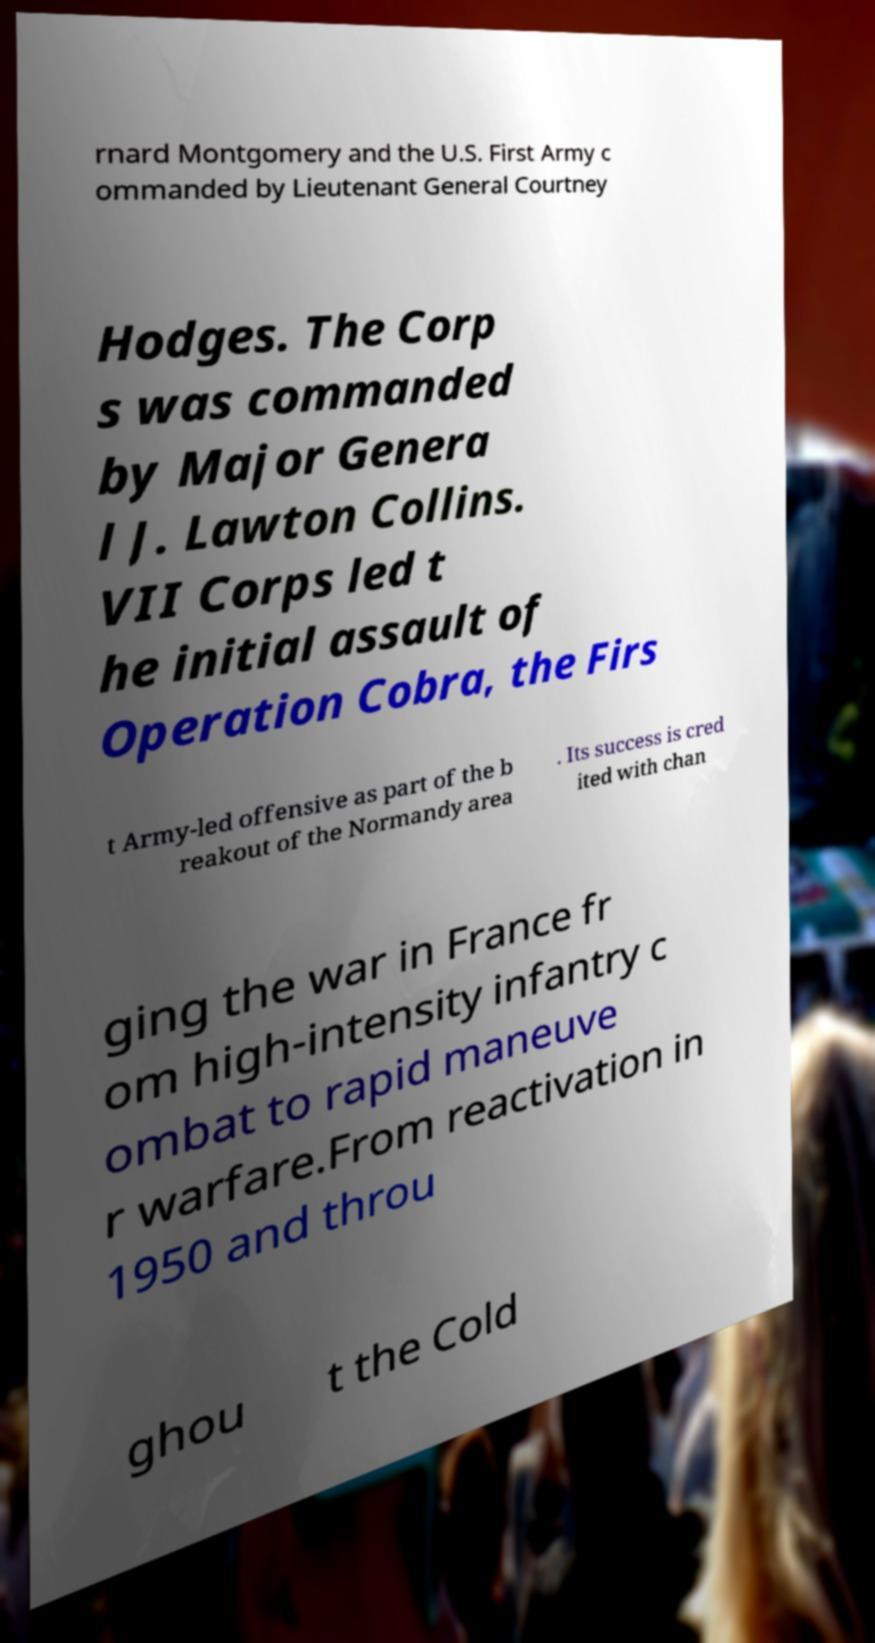There's text embedded in this image that I need extracted. Can you transcribe it verbatim? rnard Montgomery and the U.S. First Army c ommanded by Lieutenant General Courtney Hodges. The Corp s was commanded by Major Genera l J. Lawton Collins. VII Corps led t he initial assault of Operation Cobra, the Firs t Army-led offensive as part of the b reakout of the Normandy area . Its success is cred ited with chan ging the war in France fr om high-intensity infantry c ombat to rapid maneuve r warfare.From reactivation in 1950 and throu ghou t the Cold 